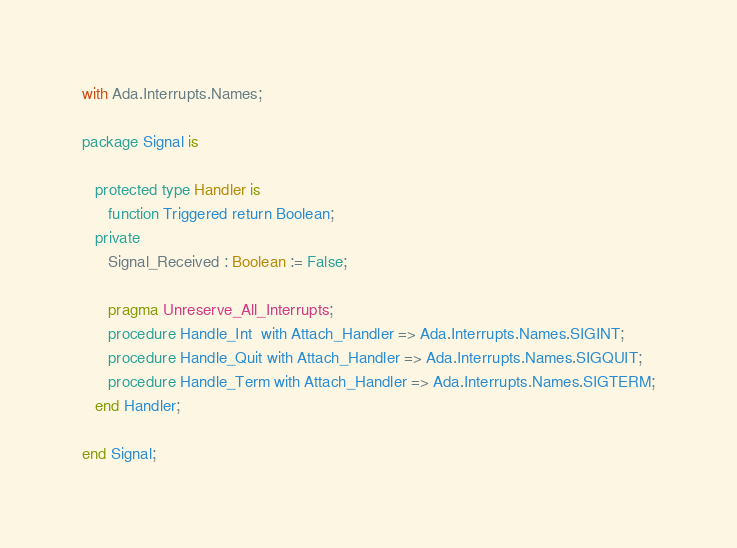Convert code to text. <code><loc_0><loc_0><loc_500><loc_500><_Ada_>with Ada.Interrupts.Names;

package Signal is

   protected type Handler is
      function Triggered return Boolean;
   private
      Signal_Received : Boolean := False;

      pragma Unreserve_All_Interrupts;
      procedure Handle_Int  with Attach_Handler => Ada.Interrupts.Names.SIGINT;
      procedure Handle_Quit with Attach_Handler => Ada.Interrupts.Names.SIGQUIT;
      procedure Handle_Term with Attach_Handler => Ada.Interrupts.Names.SIGTERM;
   end Handler;

end Signal;
</code> 